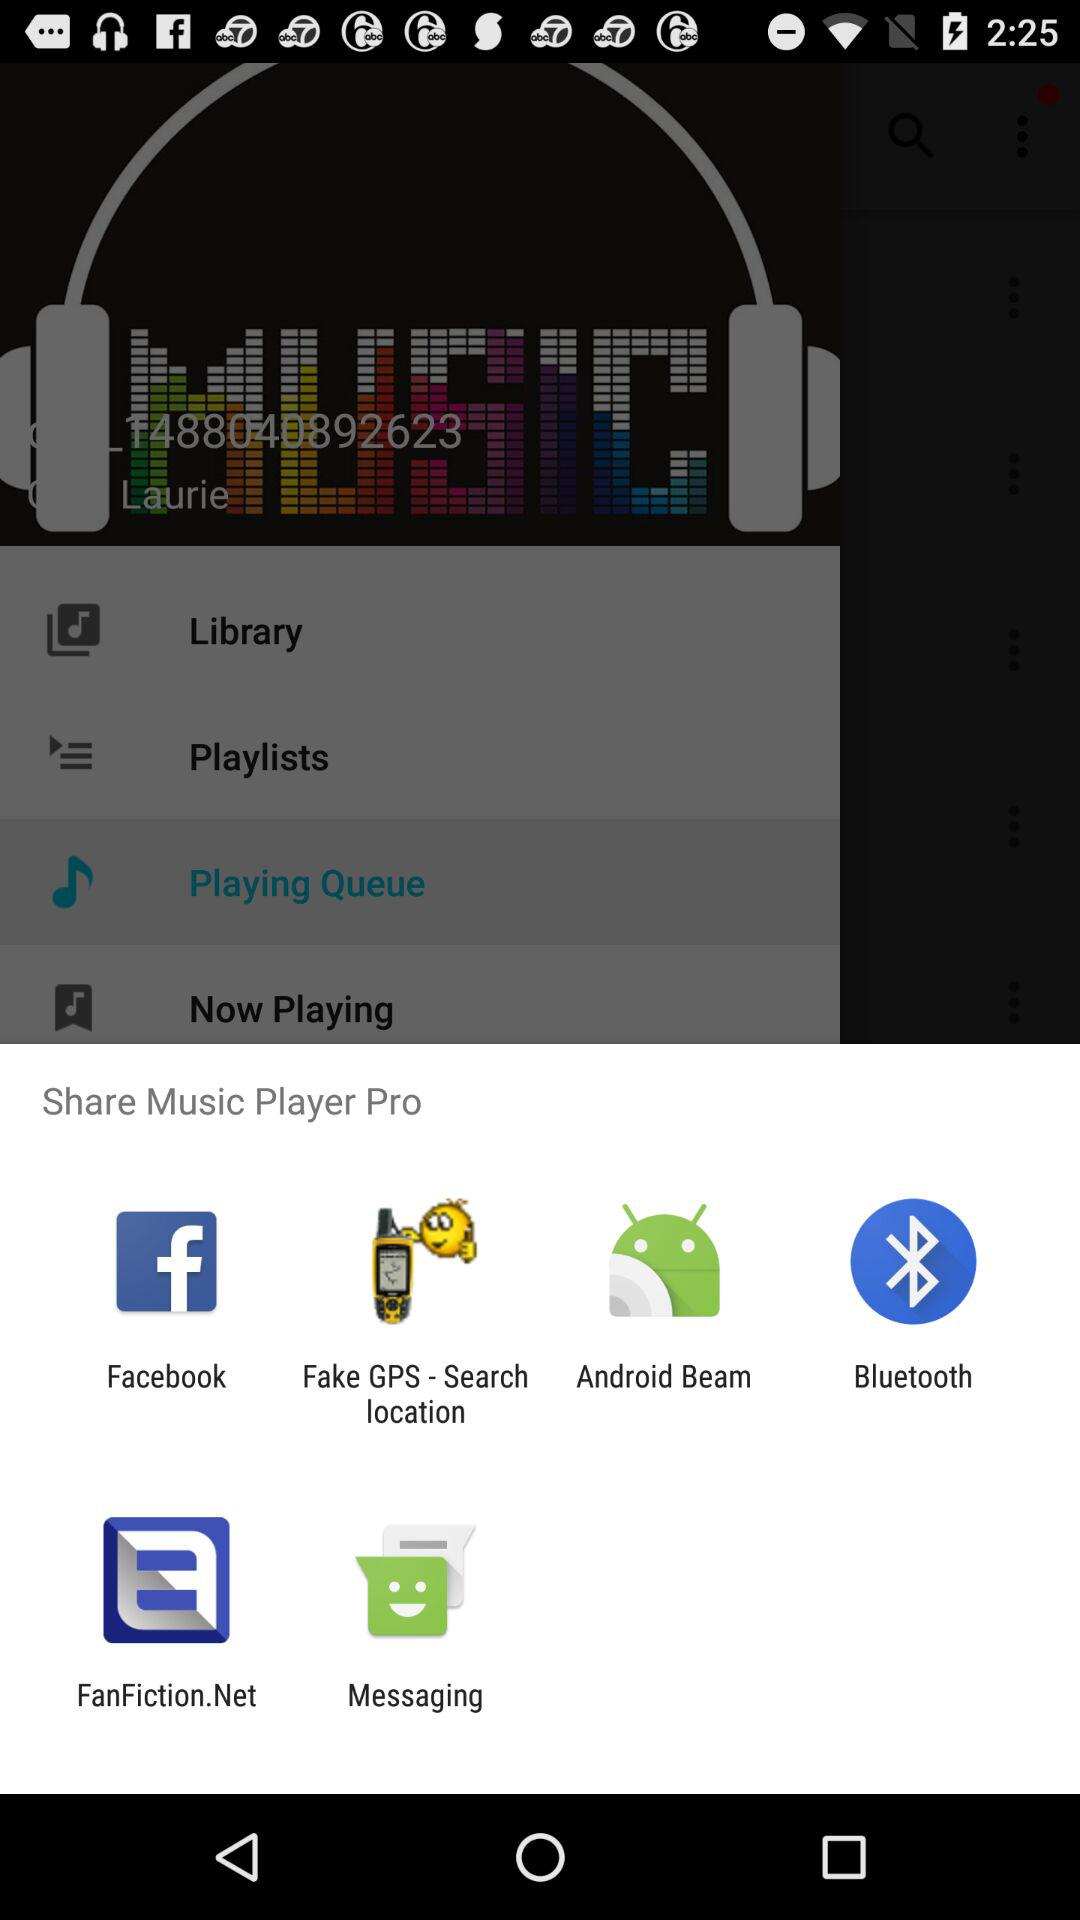Through what application can we share the "Music Player Pro"? You can share through "Facebook", "Fake GPS-Search location", "Android Beam", "Bluetooth", "FanFiction.Net", and "Messaging". 